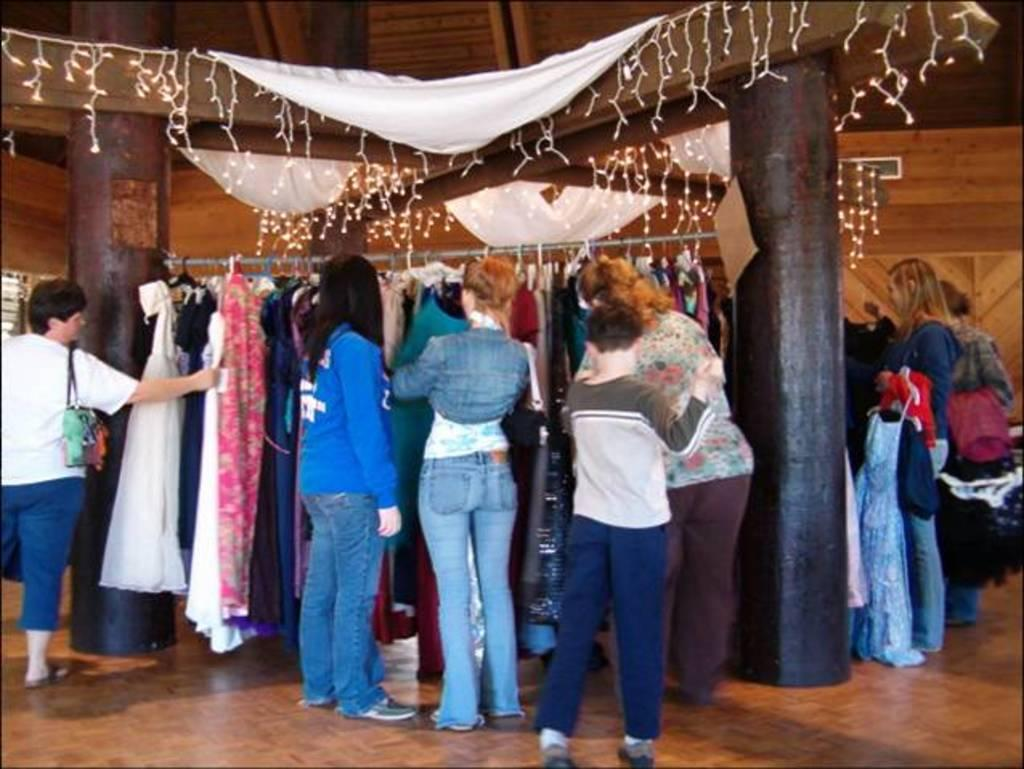What is happening in the image? There are persons standing in the image. What can be seen in the background of the image? There are clothes, pillars, and lighting in the background of the image. What type of robin can be seen perched on the pillar in the image? There is no robin present in the image; it only features persons standing and elements in the background. 